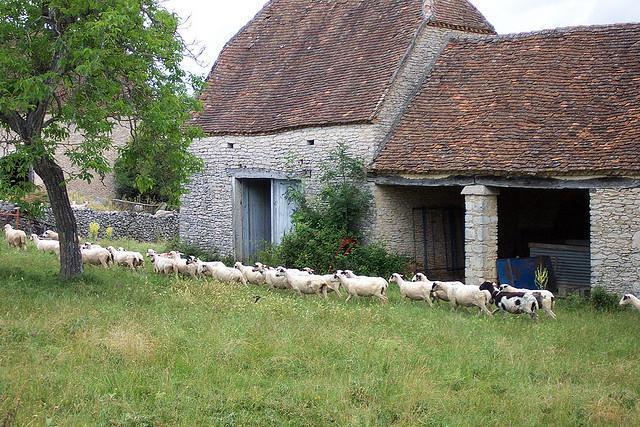How many of the sheep are black and white?
Give a very brief answer. 1. How many people are sitting on the bench?
Give a very brief answer. 0. 